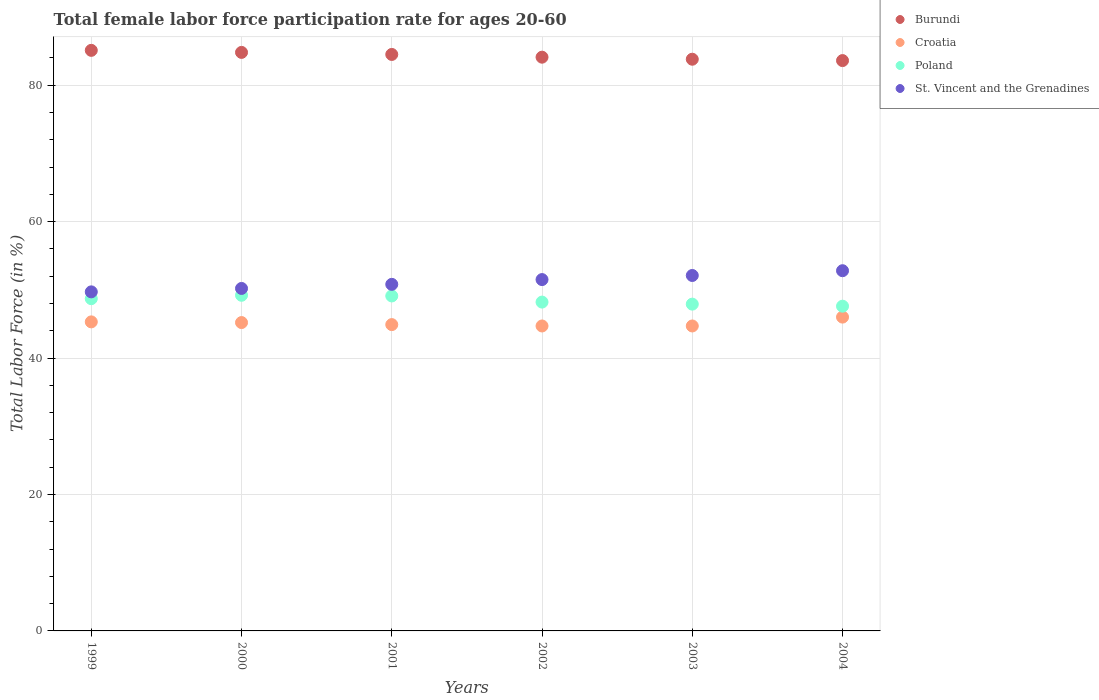How many different coloured dotlines are there?
Offer a very short reply. 4. Is the number of dotlines equal to the number of legend labels?
Give a very brief answer. Yes. What is the female labor force participation rate in Poland in 2000?
Make the answer very short. 49.2. Across all years, what is the maximum female labor force participation rate in Burundi?
Your answer should be compact. 85.1. Across all years, what is the minimum female labor force participation rate in Croatia?
Your answer should be very brief. 44.7. In which year was the female labor force participation rate in St. Vincent and the Grenadines maximum?
Provide a succinct answer. 2004. In which year was the female labor force participation rate in St. Vincent and the Grenadines minimum?
Offer a very short reply. 1999. What is the total female labor force participation rate in Croatia in the graph?
Your answer should be compact. 270.8. What is the difference between the female labor force participation rate in Poland in 2000 and that in 2001?
Give a very brief answer. 0.1. What is the difference between the female labor force participation rate in St. Vincent and the Grenadines in 2002 and the female labor force participation rate in Croatia in 2003?
Offer a terse response. 6.8. What is the average female labor force participation rate in Burundi per year?
Your answer should be compact. 84.32. In the year 1999, what is the difference between the female labor force participation rate in Burundi and female labor force participation rate in St. Vincent and the Grenadines?
Give a very brief answer. 35.4. What is the ratio of the female labor force participation rate in Poland in 2000 to that in 2002?
Provide a short and direct response. 1.02. Is the female labor force participation rate in Croatia in 2000 less than that in 2003?
Make the answer very short. No. What is the difference between the highest and the second highest female labor force participation rate in Burundi?
Ensure brevity in your answer.  0.3. In how many years, is the female labor force participation rate in Poland greater than the average female labor force participation rate in Poland taken over all years?
Make the answer very short. 3. Is the female labor force participation rate in St. Vincent and the Grenadines strictly greater than the female labor force participation rate in Croatia over the years?
Provide a short and direct response. Yes. Is the female labor force participation rate in Poland strictly less than the female labor force participation rate in Burundi over the years?
Offer a very short reply. Yes. How many dotlines are there?
Make the answer very short. 4. How many years are there in the graph?
Your response must be concise. 6. What is the difference between two consecutive major ticks on the Y-axis?
Offer a very short reply. 20. Are the values on the major ticks of Y-axis written in scientific E-notation?
Your answer should be very brief. No. What is the title of the graph?
Give a very brief answer. Total female labor force participation rate for ages 20-60. Does "Cuba" appear as one of the legend labels in the graph?
Give a very brief answer. No. What is the label or title of the X-axis?
Offer a terse response. Years. What is the Total Labor Force (in %) in Burundi in 1999?
Your answer should be very brief. 85.1. What is the Total Labor Force (in %) in Croatia in 1999?
Provide a short and direct response. 45.3. What is the Total Labor Force (in %) of Poland in 1999?
Ensure brevity in your answer.  48.7. What is the Total Labor Force (in %) in St. Vincent and the Grenadines in 1999?
Your response must be concise. 49.7. What is the Total Labor Force (in %) of Burundi in 2000?
Give a very brief answer. 84.8. What is the Total Labor Force (in %) of Croatia in 2000?
Give a very brief answer. 45.2. What is the Total Labor Force (in %) of Poland in 2000?
Offer a terse response. 49.2. What is the Total Labor Force (in %) of St. Vincent and the Grenadines in 2000?
Your response must be concise. 50.2. What is the Total Labor Force (in %) of Burundi in 2001?
Your answer should be very brief. 84.5. What is the Total Labor Force (in %) of Croatia in 2001?
Make the answer very short. 44.9. What is the Total Labor Force (in %) in Poland in 2001?
Your answer should be compact. 49.1. What is the Total Labor Force (in %) of St. Vincent and the Grenadines in 2001?
Your answer should be very brief. 50.8. What is the Total Labor Force (in %) in Burundi in 2002?
Provide a succinct answer. 84.1. What is the Total Labor Force (in %) in Croatia in 2002?
Keep it short and to the point. 44.7. What is the Total Labor Force (in %) in Poland in 2002?
Keep it short and to the point. 48.2. What is the Total Labor Force (in %) in St. Vincent and the Grenadines in 2002?
Make the answer very short. 51.5. What is the Total Labor Force (in %) in Burundi in 2003?
Your answer should be very brief. 83.8. What is the Total Labor Force (in %) in Croatia in 2003?
Offer a very short reply. 44.7. What is the Total Labor Force (in %) of Poland in 2003?
Your answer should be very brief. 47.9. What is the Total Labor Force (in %) in St. Vincent and the Grenadines in 2003?
Offer a terse response. 52.1. What is the Total Labor Force (in %) of Burundi in 2004?
Offer a very short reply. 83.6. What is the Total Labor Force (in %) of Croatia in 2004?
Offer a terse response. 46. What is the Total Labor Force (in %) in Poland in 2004?
Your response must be concise. 47.6. What is the Total Labor Force (in %) in St. Vincent and the Grenadines in 2004?
Offer a very short reply. 52.8. Across all years, what is the maximum Total Labor Force (in %) of Burundi?
Make the answer very short. 85.1. Across all years, what is the maximum Total Labor Force (in %) in Croatia?
Your response must be concise. 46. Across all years, what is the maximum Total Labor Force (in %) of Poland?
Make the answer very short. 49.2. Across all years, what is the maximum Total Labor Force (in %) of St. Vincent and the Grenadines?
Provide a short and direct response. 52.8. Across all years, what is the minimum Total Labor Force (in %) of Burundi?
Your answer should be compact. 83.6. Across all years, what is the minimum Total Labor Force (in %) in Croatia?
Ensure brevity in your answer.  44.7. Across all years, what is the minimum Total Labor Force (in %) in Poland?
Keep it short and to the point. 47.6. Across all years, what is the minimum Total Labor Force (in %) in St. Vincent and the Grenadines?
Give a very brief answer. 49.7. What is the total Total Labor Force (in %) of Burundi in the graph?
Make the answer very short. 505.9. What is the total Total Labor Force (in %) in Croatia in the graph?
Offer a very short reply. 270.8. What is the total Total Labor Force (in %) in Poland in the graph?
Offer a very short reply. 290.7. What is the total Total Labor Force (in %) of St. Vincent and the Grenadines in the graph?
Offer a very short reply. 307.1. What is the difference between the Total Labor Force (in %) in Croatia in 1999 and that in 2000?
Your answer should be compact. 0.1. What is the difference between the Total Labor Force (in %) in Burundi in 1999 and that in 2001?
Offer a very short reply. 0.6. What is the difference between the Total Labor Force (in %) in St. Vincent and the Grenadines in 1999 and that in 2001?
Your answer should be compact. -1.1. What is the difference between the Total Labor Force (in %) of Burundi in 1999 and that in 2002?
Provide a short and direct response. 1. What is the difference between the Total Labor Force (in %) in Croatia in 1999 and that in 2002?
Your response must be concise. 0.6. What is the difference between the Total Labor Force (in %) of St. Vincent and the Grenadines in 1999 and that in 2003?
Provide a succinct answer. -2.4. What is the difference between the Total Labor Force (in %) of Burundi in 1999 and that in 2004?
Keep it short and to the point. 1.5. What is the difference between the Total Labor Force (in %) in Poland in 2000 and that in 2001?
Your response must be concise. 0.1. What is the difference between the Total Labor Force (in %) in Croatia in 2000 and that in 2002?
Give a very brief answer. 0.5. What is the difference between the Total Labor Force (in %) in Burundi in 2000 and that in 2003?
Your response must be concise. 1. What is the difference between the Total Labor Force (in %) of Croatia in 2000 and that in 2003?
Ensure brevity in your answer.  0.5. What is the difference between the Total Labor Force (in %) in Poland in 2000 and that in 2003?
Your answer should be compact. 1.3. What is the difference between the Total Labor Force (in %) of Burundi in 2000 and that in 2004?
Give a very brief answer. 1.2. What is the difference between the Total Labor Force (in %) of Poland in 2000 and that in 2004?
Make the answer very short. 1.6. What is the difference between the Total Labor Force (in %) in Poland in 2001 and that in 2002?
Ensure brevity in your answer.  0.9. What is the difference between the Total Labor Force (in %) of Croatia in 2001 and that in 2003?
Offer a terse response. 0.2. What is the difference between the Total Labor Force (in %) in Burundi in 2001 and that in 2004?
Your answer should be very brief. 0.9. What is the difference between the Total Labor Force (in %) of Croatia in 2001 and that in 2004?
Offer a very short reply. -1.1. What is the difference between the Total Labor Force (in %) of St. Vincent and the Grenadines in 2001 and that in 2004?
Your response must be concise. -2. What is the difference between the Total Labor Force (in %) in Croatia in 2002 and that in 2003?
Provide a short and direct response. 0. What is the difference between the Total Labor Force (in %) of St. Vincent and the Grenadines in 2002 and that in 2003?
Keep it short and to the point. -0.6. What is the difference between the Total Labor Force (in %) in Burundi in 2002 and that in 2004?
Keep it short and to the point. 0.5. What is the difference between the Total Labor Force (in %) in Croatia in 2002 and that in 2004?
Offer a terse response. -1.3. What is the difference between the Total Labor Force (in %) of St. Vincent and the Grenadines in 2002 and that in 2004?
Give a very brief answer. -1.3. What is the difference between the Total Labor Force (in %) of Croatia in 2003 and that in 2004?
Your answer should be compact. -1.3. What is the difference between the Total Labor Force (in %) in Poland in 2003 and that in 2004?
Ensure brevity in your answer.  0.3. What is the difference between the Total Labor Force (in %) in St. Vincent and the Grenadines in 2003 and that in 2004?
Provide a short and direct response. -0.7. What is the difference between the Total Labor Force (in %) in Burundi in 1999 and the Total Labor Force (in %) in Croatia in 2000?
Offer a very short reply. 39.9. What is the difference between the Total Labor Force (in %) of Burundi in 1999 and the Total Labor Force (in %) of Poland in 2000?
Your answer should be very brief. 35.9. What is the difference between the Total Labor Force (in %) in Burundi in 1999 and the Total Labor Force (in %) in St. Vincent and the Grenadines in 2000?
Your answer should be compact. 34.9. What is the difference between the Total Labor Force (in %) of Croatia in 1999 and the Total Labor Force (in %) of Poland in 2000?
Provide a succinct answer. -3.9. What is the difference between the Total Labor Force (in %) of Croatia in 1999 and the Total Labor Force (in %) of St. Vincent and the Grenadines in 2000?
Offer a very short reply. -4.9. What is the difference between the Total Labor Force (in %) of Poland in 1999 and the Total Labor Force (in %) of St. Vincent and the Grenadines in 2000?
Your response must be concise. -1.5. What is the difference between the Total Labor Force (in %) in Burundi in 1999 and the Total Labor Force (in %) in Croatia in 2001?
Ensure brevity in your answer.  40.2. What is the difference between the Total Labor Force (in %) of Burundi in 1999 and the Total Labor Force (in %) of St. Vincent and the Grenadines in 2001?
Offer a terse response. 34.3. What is the difference between the Total Labor Force (in %) of Croatia in 1999 and the Total Labor Force (in %) of Poland in 2001?
Your response must be concise. -3.8. What is the difference between the Total Labor Force (in %) of Poland in 1999 and the Total Labor Force (in %) of St. Vincent and the Grenadines in 2001?
Your answer should be very brief. -2.1. What is the difference between the Total Labor Force (in %) of Burundi in 1999 and the Total Labor Force (in %) of Croatia in 2002?
Make the answer very short. 40.4. What is the difference between the Total Labor Force (in %) in Burundi in 1999 and the Total Labor Force (in %) in Poland in 2002?
Give a very brief answer. 36.9. What is the difference between the Total Labor Force (in %) in Burundi in 1999 and the Total Labor Force (in %) in St. Vincent and the Grenadines in 2002?
Ensure brevity in your answer.  33.6. What is the difference between the Total Labor Force (in %) in Croatia in 1999 and the Total Labor Force (in %) in Poland in 2002?
Your answer should be compact. -2.9. What is the difference between the Total Labor Force (in %) in Croatia in 1999 and the Total Labor Force (in %) in St. Vincent and the Grenadines in 2002?
Provide a succinct answer. -6.2. What is the difference between the Total Labor Force (in %) of Burundi in 1999 and the Total Labor Force (in %) of Croatia in 2003?
Your answer should be compact. 40.4. What is the difference between the Total Labor Force (in %) of Burundi in 1999 and the Total Labor Force (in %) of Poland in 2003?
Your answer should be compact. 37.2. What is the difference between the Total Labor Force (in %) of Burundi in 1999 and the Total Labor Force (in %) of St. Vincent and the Grenadines in 2003?
Offer a very short reply. 33. What is the difference between the Total Labor Force (in %) of Croatia in 1999 and the Total Labor Force (in %) of St. Vincent and the Grenadines in 2003?
Provide a succinct answer. -6.8. What is the difference between the Total Labor Force (in %) in Poland in 1999 and the Total Labor Force (in %) in St. Vincent and the Grenadines in 2003?
Ensure brevity in your answer.  -3.4. What is the difference between the Total Labor Force (in %) of Burundi in 1999 and the Total Labor Force (in %) of Croatia in 2004?
Provide a short and direct response. 39.1. What is the difference between the Total Labor Force (in %) in Burundi in 1999 and the Total Labor Force (in %) in Poland in 2004?
Give a very brief answer. 37.5. What is the difference between the Total Labor Force (in %) in Burundi in 1999 and the Total Labor Force (in %) in St. Vincent and the Grenadines in 2004?
Ensure brevity in your answer.  32.3. What is the difference between the Total Labor Force (in %) in Croatia in 1999 and the Total Labor Force (in %) in Poland in 2004?
Provide a short and direct response. -2.3. What is the difference between the Total Labor Force (in %) of Poland in 1999 and the Total Labor Force (in %) of St. Vincent and the Grenadines in 2004?
Your answer should be compact. -4.1. What is the difference between the Total Labor Force (in %) of Burundi in 2000 and the Total Labor Force (in %) of Croatia in 2001?
Your answer should be very brief. 39.9. What is the difference between the Total Labor Force (in %) in Burundi in 2000 and the Total Labor Force (in %) in Poland in 2001?
Ensure brevity in your answer.  35.7. What is the difference between the Total Labor Force (in %) in Poland in 2000 and the Total Labor Force (in %) in St. Vincent and the Grenadines in 2001?
Make the answer very short. -1.6. What is the difference between the Total Labor Force (in %) in Burundi in 2000 and the Total Labor Force (in %) in Croatia in 2002?
Offer a very short reply. 40.1. What is the difference between the Total Labor Force (in %) in Burundi in 2000 and the Total Labor Force (in %) in Poland in 2002?
Offer a very short reply. 36.6. What is the difference between the Total Labor Force (in %) of Burundi in 2000 and the Total Labor Force (in %) of St. Vincent and the Grenadines in 2002?
Your answer should be very brief. 33.3. What is the difference between the Total Labor Force (in %) of Croatia in 2000 and the Total Labor Force (in %) of Poland in 2002?
Your answer should be compact. -3. What is the difference between the Total Labor Force (in %) of Burundi in 2000 and the Total Labor Force (in %) of Croatia in 2003?
Offer a very short reply. 40.1. What is the difference between the Total Labor Force (in %) in Burundi in 2000 and the Total Labor Force (in %) in Poland in 2003?
Offer a terse response. 36.9. What is the difference between the Total Labor Force (in %) in Burundi in 2000 and the Total Labor Force (in %) in St. Vincent and the Grenadines in 2003?
Make the answer very short. 32.7. What is the difference between the Total Labor Force (in %) in Croatia in 2000 and the Total Labor Force (in %) in Poland in 2003?
Make the answer very short. -2.7. What is the difference between the Total Labor Force (in %) of Burundi in 2000 and the Total Labor Force (in %) of Croatia in 2004?
Provide a succinct answer. 38.8. What is the difference between the Total Labor Force (in %) of Burundi in 2000 and the Total Labor Force (in %) of Poland in 2004?
Provide a short and direct response. 37.2. What is the difference between the Total Labor Force (in %) of Croatia in 2000 and the Total Labor Force (in %) of St. Vincent and the Grenadines in 2004?
Keep it short and to the point. -7.6. What is the difference between the Total Labor Force (in %) in Burundi in 2001 and the Total Labor Force (in %) in Croatia in 2002?
Make the answer very short. 39.8. What is the difference between the Total Labor Force (in %) in Burundi in 2001 and the Total Labor Force (in %) in Poland in 2002?
Keep it short and to the point. 36.3. What is the difference between the Total Labor Force (in %) of Croatia in 2001 and the Total Labor Force (in %) of Poland in 2002?
Keep it short and to the point. -3.3. What is the difference between the Total Labor Force (in %) of Burundi in 2001 and the Total Labor Force (in %) of Croatia in 2003?
Ensure brevity in your answer.  39.8. What is the difference between the Total Labor Force (in %) in Burundi in 2001 and the Total Labor Force (in %) in Poland in 2003?
Provide a short and direct response. 36.6. What is the difference between the Total Labor Force (in %) of Burundi in 2001 and the Total Labor Force (in %) of St. Vincent and the Grenadines in 2003?
Your answer should be compact. 32.4. What is the difference between the Total Labor Force (in %) of Croatia in 2001 and the Total Labor Force (in %) of Poland in 2003?
Offer a terse response. -3. What is the difference between the Total Labor Force (in %) of Burundi in 2001 and the Total Labor Force (in %) of Croatia in 2004?
Give a very brief answer. 38.5. What is the difference between the Total Labor Force (in %) in Burundi in 2001 and the Total Labor Force (in %) in Poland in 2004?
Keep it short and to the point. 36.9. What is the difference between the Total Labor Force (in %) in Burundi in 2001 and the Total Labor Force (in %) in St. Vincent and the Grenadines in 2004?
Give a very brief answer. 31.7. What is the difference between the Total Labor Force (in %) in Croatia in 2001 and the Total Labor Force (in %) in St. Vincent and the Grenadines in 2004?
Offer a terse response. -7.9. What is the difference between the Total Labor Force (in %) in Poland in 2001 and the Total Labor Force (in %) in St. Vincent and the Grenadines in 2004?
Your answer should be very brief. -3.7. What is the difference between the Total Labor Force (in %) of Burundi in 2002 and the Total Labor Force (in %) of Croatia in 2003?
Give a very brief answer. 39.4. What is the difference between the Total Labor Force (in %) of Burundi in 2002 and the Total Labor Force (in %) of Poland in 2003?
Ensure brevity in your answer.  36.2. What is the difference between the Total Labor Force (in %) in Burundi in 2002 and the Total Labor Force (in %) in St. Vincent and the Grenadines in 2003?
Ensure brevity in your answer.  32. What is the difference between the Total Labor Force (in %) in Croatia in 2002 and the Total Labor Force (in %) in Poland in 2003?
Offer a terse response. -3.2. What is the difference between the Total Labor Force (in %) in Croatia in 2002 and the Total Labor Force (in %) in St. Vincent and the Grenadines in 2003?
Make the answer very short. -7.4. What is the difference between the Total Labor Force (in %) of Poland in 2002 and the Total Labor Force (in %) of St. Vincent and the Grenadines in 2003?
Your answer should be compact. -3.9. What is the difference between the Total Labor Force (in %) in Burundi in 2002 and the Total Labor Force (in %) in Croatia in 2004?
Make the answer very short. 38.1. What is the difference between the Total Labor Force (in %) in Burundi in 2002 and the Total Labor Force (in %) in Poland in 2004?
Provide a succinct answer. 36.5. What is the difference between the Total Labor Force (in %) of Burundi in 2002 and the Total Labor Force (in %) of St. Vincent and the Grenadines in 2004?
Keep it short and to the point. 31.3. What is the difference between the Total Labor Force (in %) in Poland in 2002 and the Total Labor Force (in %) in St. Vincent and the Grenadines in 2004?
Keep it short and to the point. -4.6. What is the difference between the Total Labor Force (in %) of Burundi in 2003 and the Total Labor Force (in %) of Croatia in 2004?
Keep it short and to the point. 37.8. What is the difference between the Total Labor Force (in %) of Burundi in 2003 and the Total Labor Force (in %) of Poland in 2004?
Offer a very short reply. 36.2. What is the difference between the Total Labor Force (in %) of Burundi in 2003 and the Total Labor Force (in %) of St. Vincent and the Grenadines in 2004?
Your answer should be compact. 31. What is the average Total Labor Force (in %) in Burundi per year?
Provide a succinct answer. 84.32. What is the average Total Labor Force (in %) in Croatia per year?
Offer a terse response. 45.13. What is the average Total Labor Force (in %) of Poland per year?
Offer a terse response. 48.45. What is the average Total Labor Force (in %) in St. Vincent and the Grenadines per year?
Offer a terse response. 51.18. In the year 1999, what is the difference between the Total Labor Force (in %) of Burundi and Total Labor Force (in %) of Croatia?
Your response must be concise. 39.8. In the year 1999, what is the difference between the Total Labor Force (in %) in Burundi and Total Labor Force (in %) in Poland?
Keep it short and to the point. 36.4. In the year 1999, what is the difference between the Total Labor Force (in %) in Burundi and Total Labor Force (in %) in St. Vincent and the Grenadines?
Your answer should be compact. 35.4. In the year 1999, what is the difference between the Total Labor Force (in %) in Croatia and Total Labor Force (in %) in Poland?
Your answer should be compact. -3.4. In the year 1999, what is the difference between the Total Labor Force (in %) of Croatia and Total Labor Force (in %) of St. Vincent and the Grenadines?
Offer a terse response. -4.4. In the year 2000, what is the difference between the Total Labor Force (in %) of Burundi and Total Labor Force (in %) of Croatia?
Make the answer very short. 39.6. In the year 2000, what is the difference between the Total Labor Force (in %) in Burundi and Total Labor Force (in %) in Poland?
Your response must be concise. 35.6. In the year 2000, what is the difference between the Total Labor Force (in %) of Burundi and Total Labor Force (in %) of St. Vincent and the Grenadines?
Keep it short and to the point. 34.6. In the year 2000, what is the difference between the Total Labor Force (in %) in Croatia and Total Labor Force (in %) in Poland?
Make the answer very short. -4. In the year 2000, what is the difference between the Total Labor Force (in %) of Croatia and Total Labor Force (in %) of St. Vincent and the Grenadines?
Provide a short and direct response. -5. In the year 2001, what is the difference between the Total Labor Force (in %) of Burundi and Total Labor Force (in %) of Croatia?
Provide a succinct answer. 39.6. In the year 2001, what is the difference between the Total Labor Force (in %) of Burundi and Total Labor Force (in %) of Poland?
Your response must be concise. 35.4. In the year 2001, what is the difference between the Total Labor Force (in %) of Burundi and Total Labor Force (in %) of St. Vincent and the Grenadines?
Your answer should be compact. 33.7. In the year 2001, what is the difference between the Total Labor Force (in %) of Croatia and Total Labor Force (in %) of Poland?
Your response must be concise. -4.2. In the year 2001, what is the difference between the Total Labor Force (in %) of Croatia and Total Labor Force (in %) of St. Vincent and the Grenadines?
Your answer should be very brief. -5.9. In the year 2001, what is the difference between the Total Labor Force (in %) in Poland and Total Labor Force (in %) in St. Vincent and the Grenadines?
Give a very brief answer. -1.7. In the year 2002, what is the difference between the Total Labor Force (in %) in Burundi and Total Labor Force (in %) in Croatia?
Your answer should be compact. 39.4. In the year 2002, what is the difference between the Total Labor Force (in %) of Burundi and Total Labor Force (in %) of Poland?
Provide a succinct answer. 35.9. In the year 2002, what is the difference between the Total Labor Force (in %) in Burundi and Total Labor Force (in %) in St. Vincent and the Grenadines?
Your answer should be very brief. 32.6. In the year 2002, what is the difference between the Total Labor Force (in %) of Croatia and Total Labor Force (in %) of Poland?
Provide a succinct answer. -3.5. In the year 2003, what is the difference between the Total Labor Force (in %) in Burundi and Total Labor Force (in %) in Croatia?
Provide a short and direct response. 39.1. In the year 2003, what is the difference between the Total Labor Force (in %) in Burundi and Total Labor Force (in %) in Poland?
Provide a short and direct response. 35.9. In the year 2003, what is the difference between the Total Labor Force (in %) of Burundi and Total Labor Force (in %) of St. Vincent and the Grenadines?
Your response must be concise. 31.7. In the year 2003, what is the difference between the Total Labor Force (in %) in Croatia and Total Labor Force (in %) in Poland?
Offer a terse response. -3.2. In the year 2003, what is the difference between the Total Labor Force (in %) in Croatia and Total Labor Force (in %) in St. Vincent and the Grenadines?
Give a very brief answer. -7.4. In the year 2003, what is the difference between the Total Labor Force (in %) in Poland and Total Labor Force (in %) in St. Vincent and the Grenadines?
Your response must be concise. -4.2. In the year 2004, what is the difference between the Total Labor Force (in %) of Burundi and Total Labor Force (in %) of Croatia?
Provide a succinct answer. 37.6. In the year 2004, what is the difference between the Total Labor Force (in %) in Burundi and Total Labor Force (in %) in Poland?
Give a very brief answer. 36. In the year 2004, what is the difference between the Total Labor Force (in %) of Burundi and Total Labor Force (in %) of St. Vincent and the Grenadines?
Give a very brief answer. 30.8. What is the ratio of the Total Labor Force (in %) of Burundi in 1999 to that in 2000?
Your answer should be compact. 1. What is the ratio of the Total Labor Force (in %) in Croatia in 1999 to that in 2000?
Give a very brief answer. 1. What is the ratio of the Total Labor Force (in %) of Poland in 1999 to that in 2000?
Ensure brevity in your answer.  0.99. What is the ratio of the Total Labor Force (in %) of St. Vincent and the Grenadines in 1999 to that in 2000?
Provide a short and direct response. 0.99. What is the ratio of the Total Labor Force (in %) in Burundi in 1999 to that in 2001?
Your response must be concise. 1.01. What is the ratio of the Total Labor Force (in %) of Croatia in 1999 to that in 2001?
Ensure brevity in your answer.  1.01. What is the ratio of the Total Labor Force (in %) of St. Vincent and the Grenadines in 1999 to that in 2001?
Offer a very short reply. 0.98. What is the ratio of the Total Labor Force (in %) of Burundi in 1999 to that in 2002?
Provide a succinct answer. 1.01. What is the ratio of the Total Labor Force (in %) of Croatia in 1999 to that in 2002?
Your answer should be very brief. 1.01. What is the ratio of the Total Labor Force (in %) in Poland in 1999 to that in 2002?
Keep it short and to the point. 1.01. What is the ratio of the Total Labor Force (in %) of Burundi in 1999 to that in 2003?
Provide a short and direct response. 1.02. What is the ratio of the Total Labor Force (in %) in Croatia in 1999 to that in 2003?
Ensure brevity in your answer.  1.01. What is the ratio of the Total Labor Force (in %) of Poland in 1999 to that in 2003?
Your response must be concise. 1.02. What is the ratio of the Total Labor Force (in %) in St. Vincent and the Grenadines in 1999 to that in 2003?
Provide a succinct answer. 0.95. What is the ratio of the Total Labor Force (in %) of Burundi in 1999 to that in 2004?
Ensure brevity in your answer.  1.02. What is the ratio of the Total Labor Force (in %) of Poland in 1999 to that in 2004?
Keep it short and to the point. 1.02. What is the ratio of the Total Labor Force (in %) of St. Vincent and the Grenadines in 1999 to that in 2004?
Your response must be concise. 0.94. What is the ratio of the Total Labor Force (in %) of Croatia in 2000 to that in 2001?
Offer a very short reply. 1.01. What is the ratio of the Total Labor Force (in %) of St. Vincent and the Grenadines in 2000 to that in 2001?
Give a very brief answer. 0.99. What is the ratio of the Total Labor Force (in %) of Burundi in 2000 to that in 2002?
Give a very brief answer. 1.01. What is the ratio of the Total Labor Force (in %) of Croatia in 2000 to that in 2002?
Make the answer very short. 1.01. What is the ratio of the Total Labor Force (in %) of Poland in 2000 to that in 2002?
Your answer should be very brief. 1.02. What is the ratio of the Total Labor Force (in %) in St. Vincent and the Grenadines in 2000 to that in 2002?
Offer a terse response. 0.97. What is the ratio of the Total Labor Force (in %) in Burundi in 2000 to that in 2003?
Your answer should be compact. 1.01. What is the ratio of the Total Labor Force (in %) in Croatia in 2000 to that in 2003?
Provide a succinct answer. 1.01. What is the ratio of the Total Labor Force (in %) of Poland in 2000 to that in 2003?
Make the answer very short. 1.03. What is the ratio of the Total Labor Force (in %) in St. Vincent and the Grenadines in 2000 to that in 2003?
Offer a very short reply. 0.96. What is the ratio of the Total Labor Force (in %) in Burundi in 2000 to that in 2004?
Make the answer very short. 1.01. What is the ratio of the Total Labor Force (in %) in Croatia in 2000 to that in 2004?
Give a very brief answer. 0.98. What is the ratio of the Total Labor Force (in %) of Poland in 2000 to that in 2004?
Keep it short and to the point. 1.03. What is the ratio of the Total Labor Force (in %) of St. Vincent and the Grenadines in 2000 to that in 2004?
Provide a short and direct response. 0.95. What is the ratio of the Total Labor Force (in %) in Croatia in 2001 to that in 2002?
Keep it short and to the point. 1. What is the ratio of the Total Labor Force (in %) of Poland in 2001 to that in 2002?
Your answer should be very brief. 1.02. What is the ratio of the Total Labor Force (in %) of St. Vincent and the Grenadines in 2001 to that in 2002?
Offer a terse response. 0.99. What is the ratio of the Total Labor Force (in %) of Burundi in 2001 to that in 2003?
Provide a short and direct response. 1.01. What is the ratio of the Total Labor Force (in %) of Croatia in 2001 to that in 2003?
Make the answer very short. 1. What is the ratio of the Total Labor Force (in %) in Poland in 2001 to that in 2003?
Offer a very short reply. 1.03. What is the ratio of the Total Labor Force (in %) of Burundi in 2001 to that in 2004?
Give a very brief answer. 1.01. What is the ratio of the Total Labor Force (in %) in Croatia in 2001 to that in 2004?
Your response must be concise. 0.98. What is the ratio of the Total Labor Force (in %) in Poland in 2001 to that in 2004?
Your answer should be very brief. 1.03. What is the ratio of the Total Labor Force (in %) of St. Vincent and the Grenadines in 2001 to that in 2004?
Keep it short and to the point. 0.96. What is the ratio of the Total Labor Force (in %) of Croatia in 2002 to that in 2003?
Your response must be concise. 1. What is the ratio of the Total Labor Force (in %) in St. Vincent and the Grenadines in 2002 to that in 2003?
Make the answer very short. 0.99. What is the ratio of the Total Labor Force (in %) of Burundi in 2002 to that in 2004?
Make the answer very short. 1.01. What is the ratio of the Total Labor Force (in %) of Croatia in 2002 to that in 2004?
Offer a very short reply. 0.97. What is the ratio of the Total Labor Force (in %) in Poland in 2002 to that in 2004?
Give a very brief answer. 1.01. What is the ratio of the Total Labor Force (in %) in St. Vincent and the Grenadines in 2002 to that in 2004?
Your response must be concise. 0.98. What is the ratio of the Total Labor Force (in %) of Croatia in 2003 to that in 2004?
Offer a terse response. 0.97. What is the ratio of the Total Labor Force (in %) in St. Vincent and the Grenadines in 2003 to that in 2004?
Ensure brevity in your answer.  0.99. What is the difference between the highest and the second highest Total Labor Force (in %) in Burundi?
Provide a succinct answer. 0.3. What is the difference between the highest and the second highest Total Labor Force (in %) in Croatia?
Give a very brief answer. 0.7. What is the difference between the highest and the second highest Total Labor Force (in %) in St. Vincent and the Grenadines?
Offer a terse response. 0.7. What is the difference between the highest and the lowest Total Labor Force (in %) of Poland?
Your answer should be very brief. 1.6. 